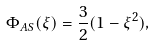Convert formula to latex. <formula><loc_0><loc_0><loc_500><loc_500>\Phi _ { A S } ( \xi ) = \frac { 3 } { 2 } ( 1 - \xi ^ { 2 } ) ,</formula> 